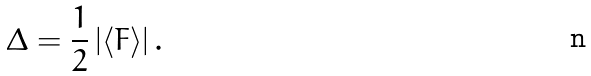Convert formula to latex. <formula><loc_0><loc_0><loc_500><loc_500>\Delta = \frac { 1 } { 2 } \left | \langle F \rangle \right | .</formula> 